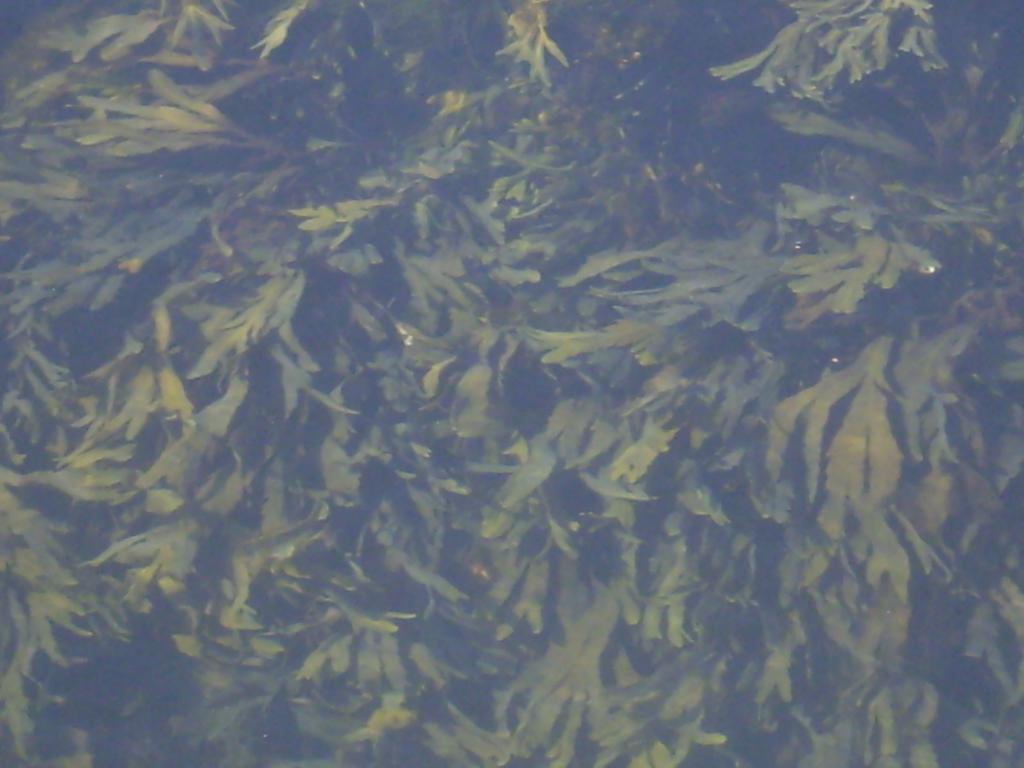How would you summarize this image in a sentence or two? This image is taken outdoors. In this image there are a few trees with green leaves. 